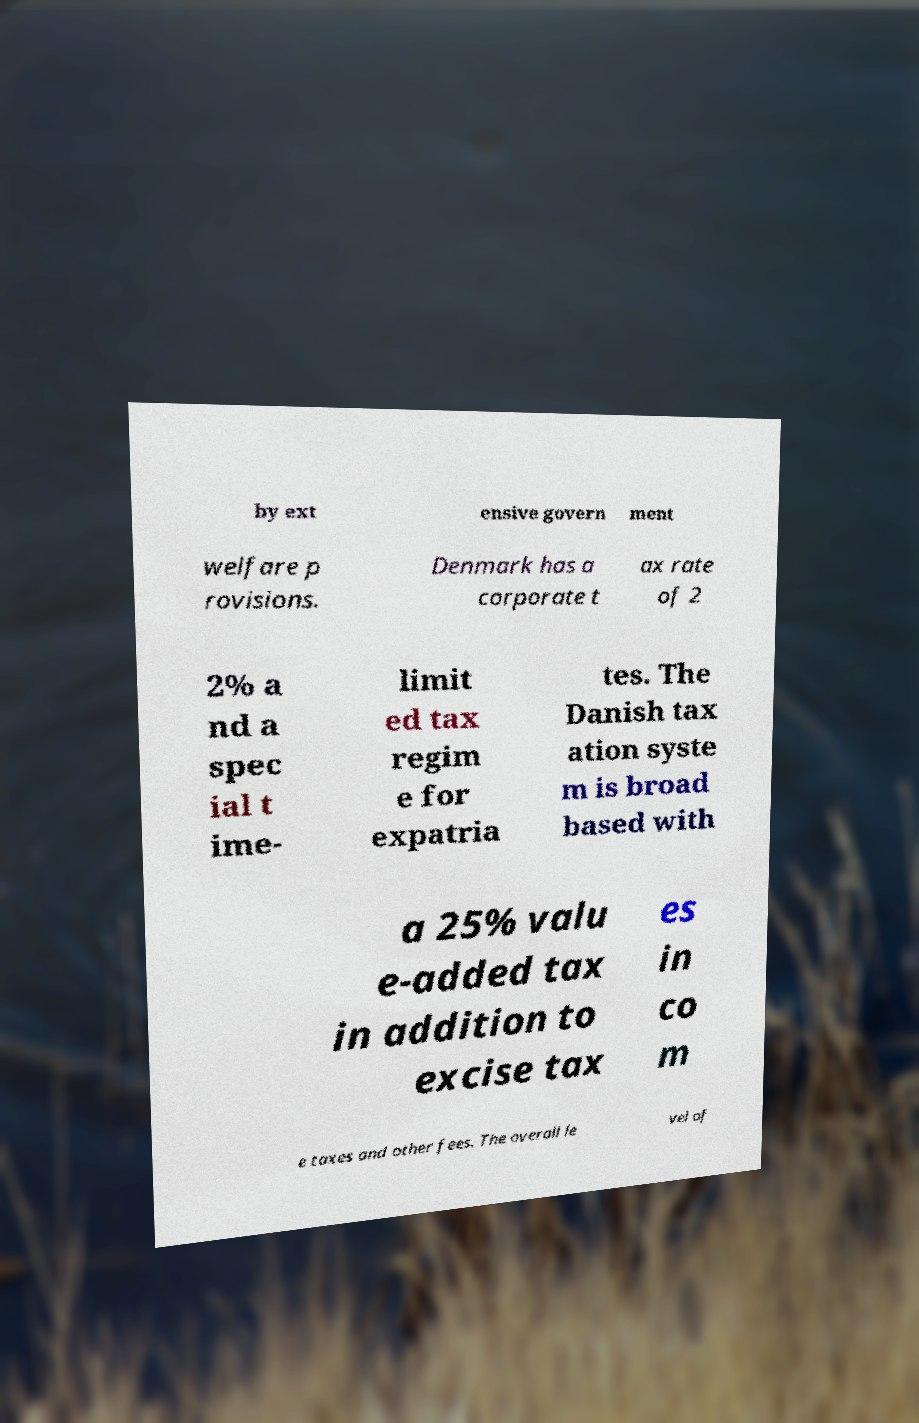There's text embedded in this image that I need extracted. Can you transcribe it verbatim? by ext ensive govern ment welfare p rovisions. Denmark has a corporate t ax rate of 2 2% a nd a spec ial t ime- limit ed tax regim e for expatria tes. The Danish tax ation syste m is broad based with a 25% valu e-added tax in addition to excise tax es in co m e taxes and other fees. The overall le vel of 